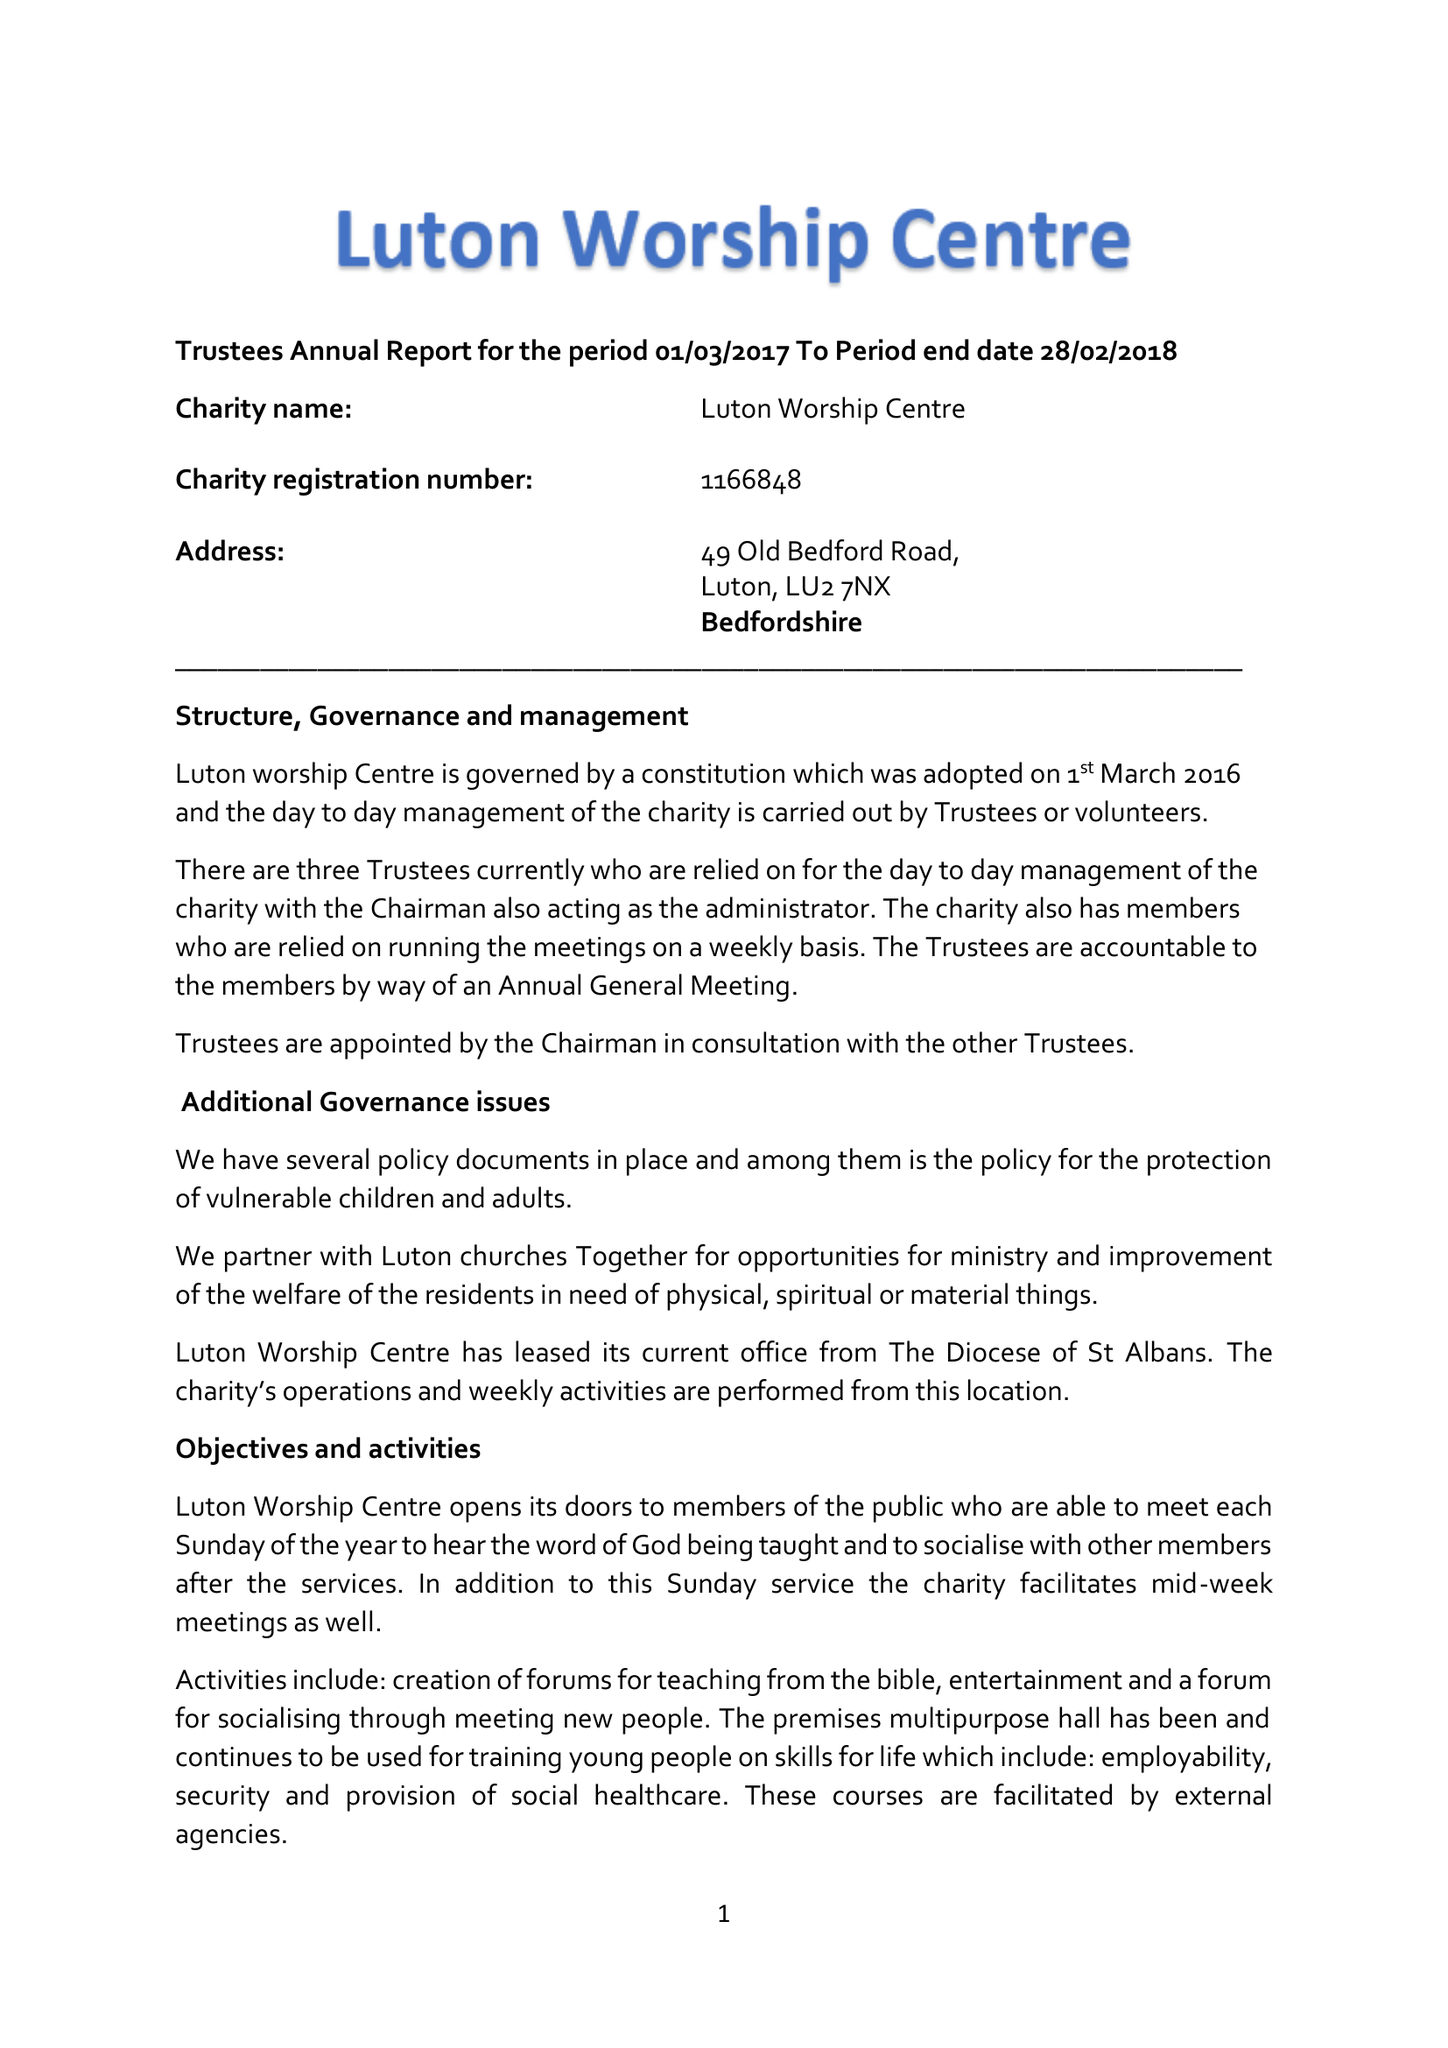What is the value for the charity_name?
Answer the question using a single word or phrase. Luton Worship Centre 